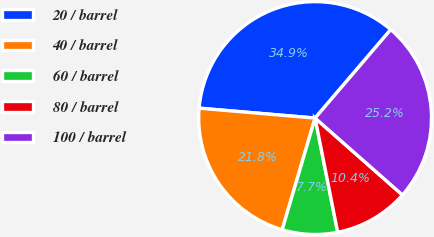Convert chart. <chart><loc_0><loc_0><loc_500><loc_500><pie_chart><fcel>20 / barrel<fcel>40 / barrel<fcel>60 / barrel<fcel>80 / barrel<fcel>100 / barrel<nl><fcel>34.9%<fcel>21.79%<fcel>7.67%<fcel>10.4%<fcel>25.23%<nl></chart> 